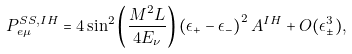<formula> <loc_0><loc_0><loc_500><loc_500>P _ { e \mu } ^ { S S , I H } = 4 \sin ^ { 2 } \left ( \frac { M ^ { 2 } L } { 4 E _ { \nu } } \right ) \left ( \epsilon _ { + } - \epsilon _ { - } \right ) ^ { 2 } A ^ { I H } + O ( \epsilon _ { \pm } ^ { 3 } ) ,</formula> 